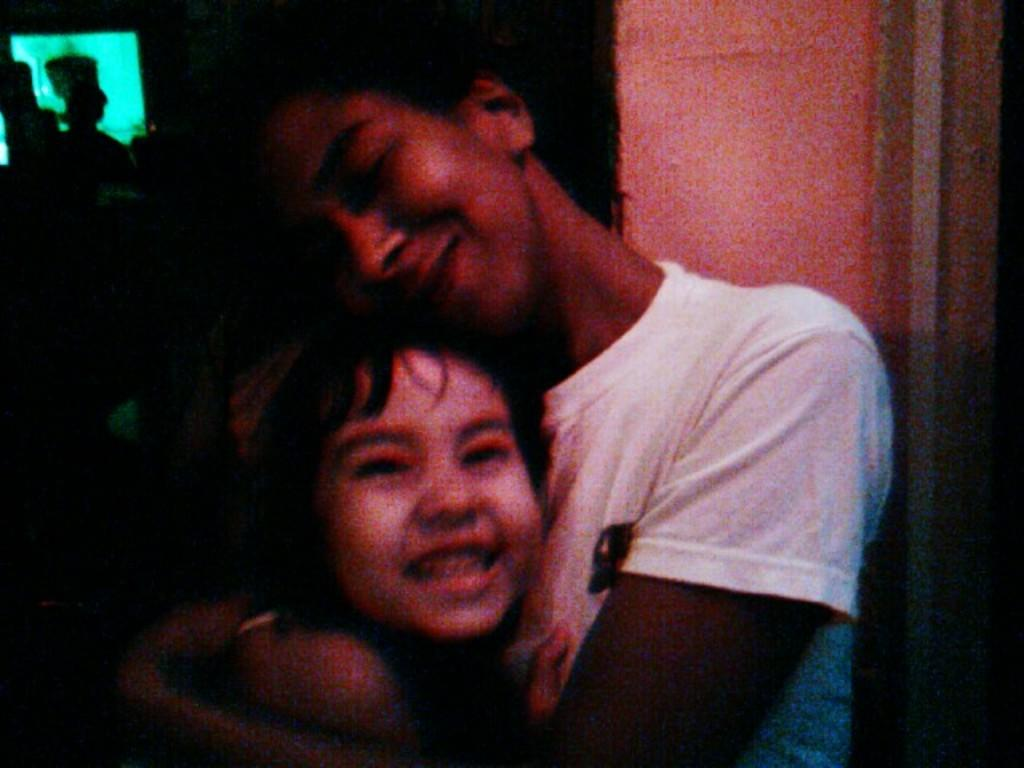Who is the main subject in the image? There is a man in the image. What is the man wearing? The man is wearing a white t-shirt. What is the man doing in the image? The man is holding a baby. What can be seen in the background of the image? There is a wall in the background of the image. How would you describe the lighting in the image? The background of the image is dark. What type of jelly can be seen on the wall in the image? There is no jelly present on the wall or in the image. How does the man point to the recess in the image? The man is not pointing to a recess in the image; he is holding a baby. 